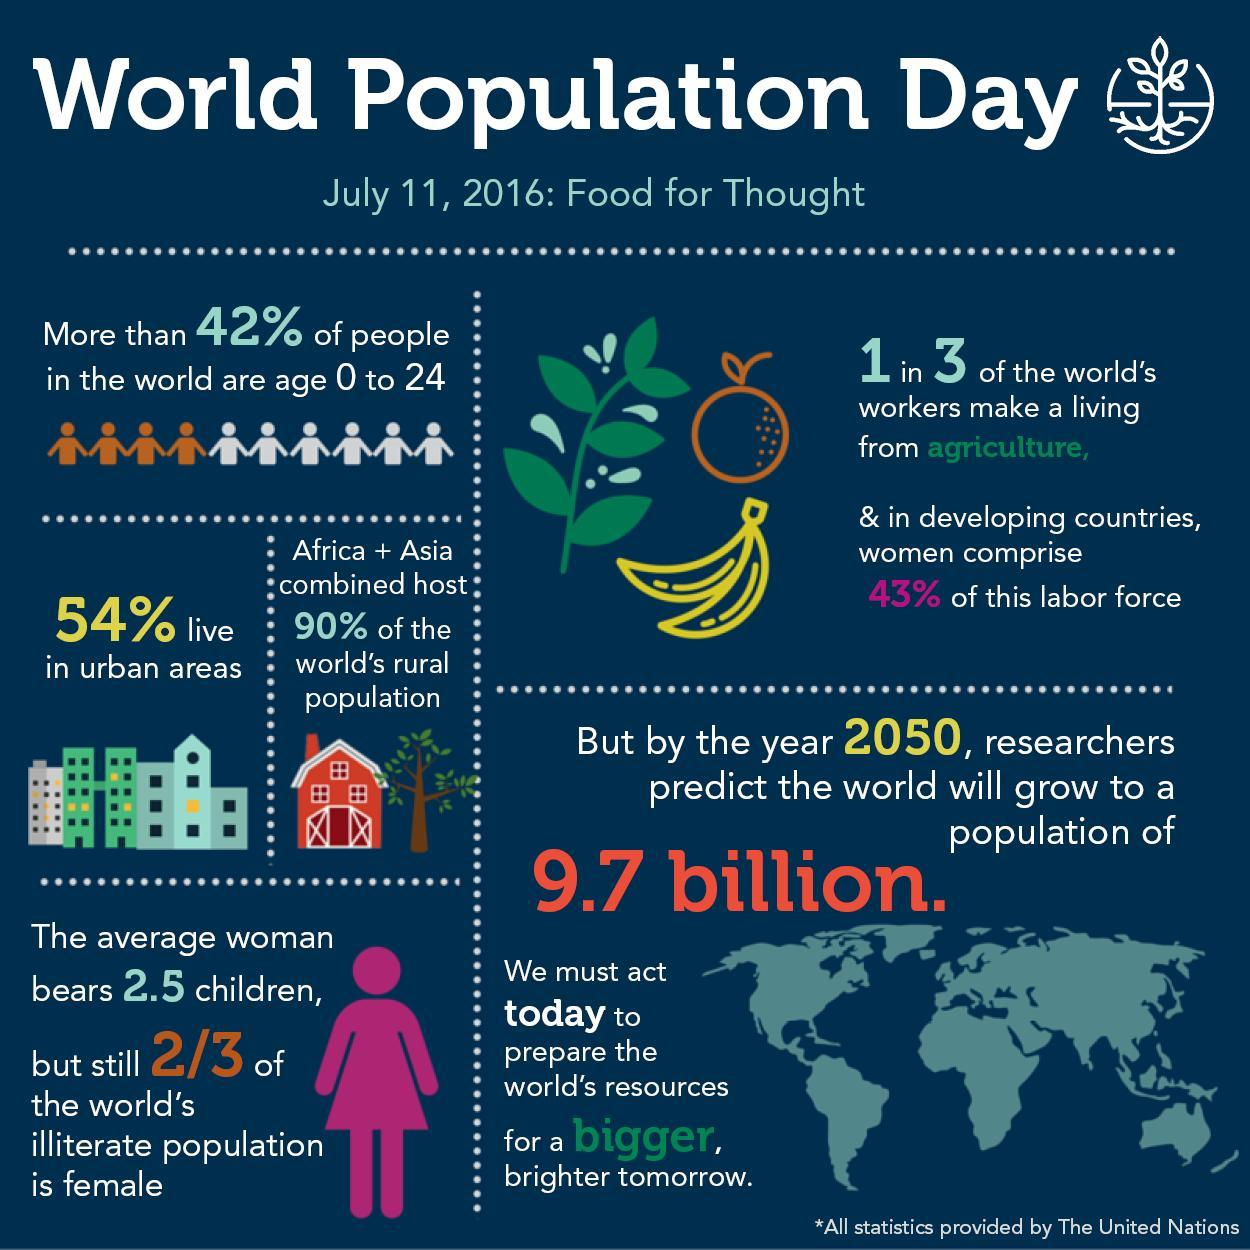What percentage comprise the agricultural labor force who are not women?
Answer the question with a short phrase. 57% What percentage of the world's workers make a living from agriculture? 33.33% What percentage of the world's illiterate population is female? 66.67% What percentage of people in the world are older than 24 years? 58% 